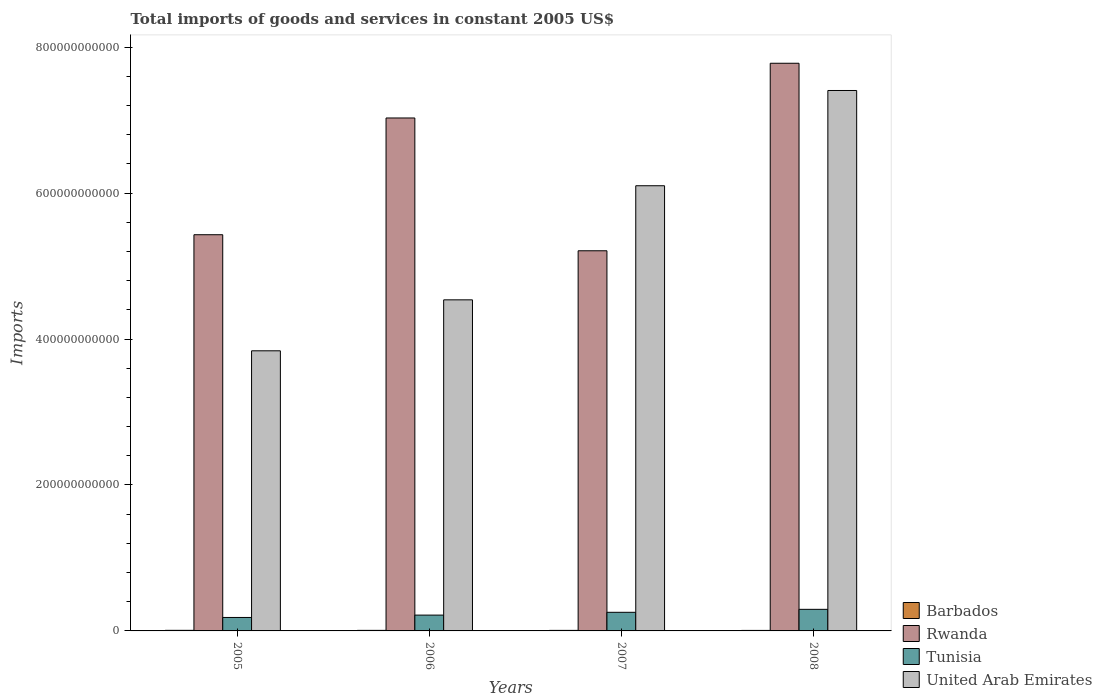How many different coloured bars are there?
Give a very brief answer. 4. How many groups of bars are there?
Give a very brief answer. 4. Are the number of bars per tick equal to the number of legend labels?
Your answer should be very brief. Yes. How many bars are there on the 3rd tick from the left?
Your answer should be compact. 4. How many bars are there on the 2nd tick from the right?
Give a very brief answer. 4. In how many cases, is the number of bars for a given year not equal to the number of legend labels?
Offer a very short reply. 0. What is the total imports of goods and services in United Arab Emirates in 2005?
Give a very brief answer. 3.84e+11. Across all years, what is the maximum total imports of goods and services in Tunisia?
Provide a short and direct response. 2.96e+1. Across all years, what is the minimum total imports of goods and services in Barbados?
Your response must be concise. 6.89e+08. In which year was the total imports of goods and services in Rwanda maximum?
Provide a short and direct response. 2008. In which year was the total imports of goods and services in Barbados minimum?
Keep it short and to the point. 2008. What is the total total imports of goods and services in Barbados in the graph?
Provide a short and direct response. 2.98e+09. What is the difference between the total imports of goods and services in United Arab Emirates in 2005 and that in 2006?
Offer a very short reply. -6.99e+1. What is the difference between the total imports of goods and services in Barbados in 2008 and the total imports of goods and services in Tunisia in 2006?
Provide a short and direct response. -2.10e+1. What is the average total imports of goods and services in Rwanda per year?
Make the answer very short. 6.36e+11. In the year 2008, what is the difference between the total imports of goods and services in Rwanda and total imports of goods and services in Tunisia?
Provide a short and direct response. 7.48e+11. In how many years, is the total imports of goods and services in United Arab Emirates greater than 160000000000 US$?
Keep it short and to the point. 4. What is the ratio of the total imports of goods and services in Barbados in 2005 to that in 2007?
Ensure brevity in your answer.  1.08. What is the difference between the highest and the second highest total imports of goods and services in United Arab Emirates?
Your answer should be compact. 1.31e+11. What is the difference between the highest and the lowest total imports of goods and services in Barbados?
Provide a short and direct response. 1.05e+08. In how many years, is the total imports of goods and services in Rwanda greater than the average total imports of goods and services in Rwanda taken over all years?
Provide a short and direct response. 2. Is the sum of the total imports of goods and services in United Arab Emirates in 2005 and 2007 greater than the maximum total imports of goods and services in Rwanda across all years?
Offer a terse response. Yes. Is it the case that in every year, the sum of the total imports of goods and services in Tunisia and total imports of goods and services in Rwanda is greater than the sum of total imports of goods and services in United Arab Emirates and total imports of goods and services in Barbados?
Make the answer very short. Yes. What does the 1st bar from the left in 2008 represents?
Provide a short and direct response. Barbados. What does the 1st bar from the right in 2005 represents?
Provide a succinct answer. United Arab Emirates. Is it the case that in every year, the sum of the total imports of goods and services in Barbados and total imports of goods and services in United Arab Emirates is greater than the total imports of goods and services in Tunisia?
Ensure brevity in your answer.  Yes. How many years are there in the graph?
Your response must be concise. 4. What is the difference between two consecutive major ticks on the Y-axis?
Give a very brief answer. 2.00e+11. Are the values on the major ticks of Y-axis written in scientific E-notation?
Your response must be concise. No. Where does the legend appear in the graph?
Your answer should be compact. Bottom right. What is the title of the graph?
Offer a very short reply. Total imports of goods and services in constant 2005 US$. What is the label or title of the X-axis?
Make the answer very short. Years. What is the label or title of the Y-axis?
Ensure brevity in your answer.  Imports. What is the Imports in Barbados in 2005?
Keep it short and to the point. 7.94e+08. What is the Imports of Rwanda in 2005?
Provide a short and direct response. 5.43e+11. What is the Imports in Tunisia in 2005?
Give a very brief answer. 1.84e+1. What is the Imports in United Arab Emirates in 2005?
Keep it short and to the point. 3.84e+11. What is the Imports in Barbados in 2006?
Offer a very short reply. 7.66e+08. What is the Imports in Rwanda in 2006?
Provide a succinct answer. 7.03e+11. What is the Imports of Tunisia in 2006?
Your answer should be very brief. 2.17e+1. What is the Imports in United Arab Emirates in 2006?
Your answer should be compact. 4.54e+11. What is the Imports in Barbados in 2007?
Your answer should be compact. 7.32e+08. What is the Imports in Rwanda in 2007?
Ensure brevity in your answer.  5.21e+11. What is the Imports in Tunisia in 2007?
Your answer should be compact. 2.55e+1. What is the Imports in United Arab Emirates in 2007?
Your response must be concise. 6.10e+11. What is the Imports in Barbados in 2008?
Ensure brevity in your answer.  6.89e+08. What is the Imports of Rwanda in 2008?
Make the answer very short. 7.78e+11. What is the Imports of Tunisia in 2008?
Your response must be concise. 2.96e+1. What is the Imports of United Arab Emirates in 2008?
Keep it short and to the point. 7.41e+11. Across all years, what is the maximum Imports of Barbados?
Provide a succinct answer. 7.94e+08. Across all years, what is the maximum Imports in Rwanda?
Your answer should be very brief. 7.78e+11. Across all years, what is the maximum Imports of Tunisia?
Your answer should be compact. 2.96e+1. Across all years, what is the maximum Imports in United Arab Emirates?
Offer a terse response. 7.41e+11. Across all years, what is the minimum Imports of Barbados?
Make the answer very short. 6.89e+08. Across all years, what is the minimum Imports of Rwanda?
Provide a succinct answer. 5.21e+11. Across all years, what is the minimum Imports of Tunisia?
Your response must be concise. 1.84e+1. Across all years, what is the minimum Imports of United Arab Emirates?
Provide a short and direct response. 3.84e+11. What is the total Imports of Barbados in the graph?
Your answer should be compact. 2.98e+09. What is the total Imports in Rwanda in the graph?
Your answer should be very brief. 2.54e+12. What is the total Imports in Tunisia in the graph?
Make the answer very short. 9.52e+1. What is the total Imports of United Arab Emirates in the graph?
Your response must be concise. 2.19e+12. What is the difference between the Imports of Barbados in 2005 and that in 2006?
Your response must be concise. 2.80e+07. What is the difference between the Imports in Rwanda in 2005 and that in 2006?
Keep it short and to the point. -1.60e+11. What is the difference between the Imports of Tunisia in 2005 and that in 2006?
Give a very brief answer. -3.24e+09. What is the difference between the Imports of United Arab Emirates in 2005 and that in 2006?
Offer a very short reply. -6.99e+1. What is the difference between the Imports in Barbados in 2005 and that in 2007?
Provide a short and direct response. 6.20e+07. What is the difference between the Imports in Rwanda in 2005 and that in 2007?
Your answer should be compact. 2.20e+1. What is the difference between the Imports of Tunisia in 2005 and that in 2007?
Keep it short and to the point. -7.08e+09. What is the difference between the Imports in United Arab Emirates in 2005 and that in 2007?
Offer a terse response. -2.26e+11. What is the difference between the Imports of Barbados in 2005 and that in 2008?
Provide a succinct answer. 1.05e+08. What is the difference between the Imports in Rwanda in 2005 and that in 2008?
Keep it short and to the point. -2.35e+11. What is the difference between the Imports of Tunisia in 2005 and that in 2008?
Your answer should be very brief. -1.11e+1. What is the difference between the Imports in United Arab Emirates in 2005 and that in 2008?
Keep it short and to the point. -3.57e+11. What is the difference between the Imports of Barbados in 2006 and that in 2007?
Make the answer very short. 3.40e+07. What is the difference between the Imports in Rwanda in 2006 and that in 2007?
Make the answer very short. 1.82e+11. What is the difference between the Imports of Tunisia in 2006 and that in 2007?
Keep it short and to the point. -3.83e+09. What is the difference between the Imports of United Arab Emirates in 2006 and that in 2007?
Your answer should be compact. -1.56e+11. What is the difference between the Imports of Barbados in 2006 and that in 2008?
Your answer should be very brief. 7.70e+07. What is the difference between the Imports in Rwanda in 2006 and that in 2008?
Give a very brief answer. -7.50e+1. What is the difference between the Imports of Tunisia in 2006 and that in 2008?
Your answer should be very brief. -7.89e+09. What is the difference between the Imports in United Arab Emirates in 2006 and that in 2008?
Provide a short and direct response. -2.87e+11. What is the difference between the Imports in Barbados in 2007 and that in 2008?
Provide a succinct answer. 4.30e+07. What is the difference between the Imports in Rwanda in 2007 and that in 2008?
Provide a short and direct response. -2.57e+11. What is the difference between the Imports in Tunisia in 2007 and that in 2008?
Your response must be concise. -4.06e+09. What is the difference between the Imports of United Arab Emirates in 2007 and that in 2008?
Ensure brevity in your answer.  -1.31e+11. What is the difference between the Imports of Barbados in 2005 and the Imports of Rwanda in 2006?
Provide a succinct answer. -7.02e+11. What is the difference between the Imports in Barbados in 2005 and the Imports in Tunisia in 2006?
Provide a short and direct response. -2.09e+1. What is the difference between the Imports in Barbados in 2005 and the Imports in United Arab Emirates in 2006?
Keep it short and to the point. -4.53e+11. What is the difference between the Imports of Rwanda in 2005 and the Imports of Tunisia in 2006?
Keep it short and to the point. 5.21e+11. What is the difference between the Imports in Rwanda in 2005 and the Imports in United Arab Emirates in 2006?
Keep it short and to the point. 8.92e+1. What is the difference between the Imports of Tunisia in 2005 and the Imports of United Arab Emirates in 2006?
Ensure brevity in your answer.  -4.35e+11. What is the difference between the Imports in Barbados in 2005 and the Imports in Rwanda in 2007?
Make the answer very short. -5.20e+11. What is the difference between the Imports in Barbados in 2005 and the Imports in Tunisia in 2007?
Your response must be concise. -2.47e+1. What is the difference between the Imports in Barbados in 2005 and the Imports in United Arab Emirates in 2007?
Keep it short and to the point. -6.09e+11. What is the difference between the Imports in Rwanda in 2005 and the Imports in Tunisia in 2007?
Ensure brevity in your answer.  5.17e+11. What is the difference between the Imports in Rwanda in 2005 and the Imports in United Arab Emirates in 2007?
Your answer should be compact. -6.71e+1. What is the difference between the Imports of Tunisia in 2005 and the Imports of United Arab Emirates in 2007?
Offer a very short reply. -5.92e+11. What is the difference between the Imports in Barbados in 2005 and the Imports in Rwanda in 2008?
Keep it short and to the point. -7.77e+11. What is the difference between the Imports in Barbados in 2005 and the Imports in Tunisia in 2008?
Keep it short and to the point. -2.88e+1. What is the difference between the Imports in Barbados in 2005 and the Imports in United Arab Emirates in 2008?
Your response must be concise. -7.40e+11. What is the difference between the Imports of Rwanda in 2005 and the Imports of Tunisia in 2008?
Provide a short and direct response. 5.13e+11. What is the difference between the Imports in Rwanda in 2005 and the Imports in United Arab Emirates in 2008?
Provide a succinct answer. -1.98e+11. What is the difference between the Imports in Tunisia in 2005 and the Imports in United Arab Emirates in 2008?
Provide a succinct answer. -7.22e+11. What is the difference between the Imports of Barbados in 2006 and the Imports of Rwanda in 2007?
Make the answer very short. -5.20e+11. What is the difference between the Imports in Barbados in 2006 and the Imports in Tunisia in 2007?
Offer a very short reply. -2.48e+1. What is the difference between the Imports in Barbados in 2006 and the Imports in United Arab Emirates in 2007?
Offer a very short reply. -6.09e+11. What is the difference between the Imports of Rwanda in 2006 and the Imports of Tunisia in 2007?
Keep it short and to the point. 6.77e+11. What is the difference between the Imports of Rwanda in 2006 and the Imports of United Arab Emirates in 2007?
Offer a very short reply. 9.29e+1. What is the difference between the Imports in Tunisia in 2006 and the Imports in United Arab Emirates in 2007?
Your answer should be very brief. -5.88e+11. What is the difference between the Imports of Barbados in 2006 and the Imports of Rwanda in 2008?
Offer a very short reply. -7.77e+11. What is the difference between the Imports of Barbados in 2006 and the Imports of Tunisia in 2008?
Give a very brief answer. -2.88e+1. What is the difference between the Imports of Barbados in 2006 and the Imports of United Arab Emirates in 2008?
Your answer should be very brief. -7.40e+11. What is the difference between the Imports in Rwanda in 2006 and the Imports in Tunisia in 2008?
Give a very brief answer. 6.73e+11. What is the difference between the Imports in Rwanda in 2006 and the Imports in United Arab Emirates in 2008?
Keep it short and to the point. -3.77e+1. What is the difference between the Imports in Tunisia in 2006 and the Imports in United Arab Emirates in 2008?
Ensure brevity in your answer.  -7.19e+11. What is the difference between the Imports in Barbados in 2007 and the Imports in Rwanda in 2008?
Your answer should be very brief. -7.77e+11. What is the difference between the Imports of Barbados in 2007 and the Imports of Tunisia in 2008?
Provide a short and direct response. -2.88e+1. What is the difference between the Imports in Barbados in 2007 and the Imports in United Arab Emirates in 2008?
Your response must be concise. -7.40e+11. What is the difference between the Imports of Rwanda in 2007 and the Imports of Tunisia in 2008?
Give a very brief answer. 4.91e+11. What is the difference between the Imports of Rwanda in 2007 and the Imports of United Arab Emirates in 2008?
Ensure brevity in your answer.  -2.20e+11. What is the difference between the Imports in Tunisia in 2007 and the Imports in United Arab Emirates in 2008?
Provide a succinct answer. -7.15e+11. What is the average Imports of Barbados per year?
Your answer should be compact. 7.45e+08. What is the average Imports in Rwanda per year?
Provide a short and direct response. 6.36e+11. What is the average Imports in Tunisia per year?
Offer a terse response. 2.38e+1. What is the average Imports of United Arab Emirates per year?
Offer a terse response. 5.47e+11. In the year 2005, what is the difference between the Imports in Barbados and Imports in Rwanda?
Your answer should be very brief. -5.42e+11. In the year 2005, what is the difference between the Imports of Barbados and Imports of Tunisia?
Your answer should be very brief. -1.76e+1. In the year 2005, what is the difference between the Imports of Barbados and Imports of United Arab Emirates?
Your answer should be compact. -3.83e+11. In the year 2005, what is the difference between the Imports in Rwanda and Imports in Tunisia?
Keep it short and to the point. 5.25e+11. In the year 2005, what is the difference between the Imports in Rwanda and Imports in United Arab Emirates?
Offer a very short reply. 1.59e+11. In the year 2005, what is the difference between the Imports of Tunisia and Imports of United Arab Emirates?
Provide a succinct answer. -3.65e+11. In the year 2006, what is the difference between the Imports in Barbados and Imports in Rwanda?
Ensure brevity in your answer.  -7.02e+11. In the year 2006, what is the difference between the Imports in Barbados and Imports in Tunisia?
Give a very brief answer. -2.09e+1. In the year 2006, what is the difference between the Imports of Barbados and Imports of United Arab Emirates?
Ensure brevity in your answer.  -4.53e+11. In the year 2006, what is the difference between the Imports in Rwanda and Imports in Tunisia?
Give a very brief answer. 6.81e+11. In the year 2006, what is the difference between the Imports of Rwanda and Imports of United Arab Emirates?
Your response must be concise. 2.49e+11. In the year 2006, what is the difference between the Imports of Tunisia and Imports of United Arab Emirates?
Make the answer very short. -4.32e+11. In the year 2007, what is the difference between the Imports of Barbados and Imports of Rwanda?
Provide a succinct answer. -5.20e+11. In the year 2007, what is the difference between the Imports of Barbados and Imports of Tunisia?
Ensure brevity in your answer.  -2.48e+1. In the year 2007, what is the difference between the Imports in Barbados and Imports in United Arab Emirates?
Give a very brief answer. -6.09e+11. In the year 2007, what is the difference between the Imports of Rwanda and Imports of Tunisia?
Provide a succinct answer. 4.95e+11. In the year 2007, what is the difference between the Imports in Rwanda and Imports in United Arab Emirates?
Your response must be concise. -8.91e+1. In the year 2007, what is the difference between the Imports in Tunisia and Imports in United Arab Emirates?
Your answer should be very brief. -5.85e+11. In the year 2008, what is the difference between the Imports of Barbados and Imports of Rwanda?
Make the answer very short. -7.77e+11. In the year 2008, what is the difference between the Imports in Barbados and Imports in Tunisia?
Offer a terse response. -2.89e+1. In the year 2008, what is the difference between the Imports in Barbados and Imports in United Arab Emirates?
Ensure brevity in your answer.  -7.40e+11. In the year 2008, what is the difference between the Imports in Rwanda and Imports in Tunisia?
Ensure brevity in your answer.  7.48e+11. In the year 2008, what is the difference between the Imports of Rwanda and Imports of United Arab Emirates?
Offer a terse response. 3.73e+1. In the year 2008, what is the difference between the Imports of Tunisia and Imports of United Arab Emirates?
Provide a succinct answer. -7.11e+11. What is the ratio of the Imports of Barbados in 2005 to that in 2006?
Ensure brevity in your answer.  1.04. What is the ratio of the Imports of Rwanda in 2005 to that in 2006?
Offer a very short reply. 0.77. What is the ratio of the Imports in Tunisia in 2005 to that in 2006?
Offer a very short reply. 0.85. What is the ratio of the Imports in United Arab Emirates in 2005 to that in 2006?
Ensure brevity in your answer.  0.85. What is the ratio of the Imports in Barbados in 2005 to that in 2007?
Offer a very short reply. 1.08. What is the ratio of the Imports in Rwanda in 2005 to that in 2007?
Make the answer very short. 1.04. What is the ratio of the Imports in Tunisia in 2005 to that in 2007?
Ensure brevity in your answer.  0.72. What is the ratio of the Imports of United Arab Emirates in 2005 to that in 2007?
Your response must be concise. 0.63. What is the ratio of the Imports of Barbados in 2005 to that in 2008?
Make the answer very short. 1.15. What is the ratio of the Imports of Rwanda in 2005 to that in 2008?
Your answer should be very brief. 0.7. What is the ratio of the Imports in Tunisia in 2005 to that in 2008?
Make the answer very short. 0.62. What is the ratio of the Imports of United Arab Emirates in 2005 to that in 2008?
Provide a succinct answer. 0.52. What is the ratio of the Imports of Barbados in 2006 to that in 2007?
Ensure brevity in your answer.  1.05. What is the ratio of the Imports in Rwanda in 2006 to that in 2007?
Your answer should be compact. 1.35. What is the ratio of the Imports in Tunisia in 2006 to that in 2007?
Offer a terse response. 0.85. What is the ratio of the Imports of United Arab Emirates in 2006 to that in 2007?
Your answer should be very brief. 0.74. What is the ratio of the Imports in Barbados in 2006 to that in 2008?
Your answer should be compact. 1.11. What is the ratio of the Imports in Rwanda in 2006 to that in 2008?
Keep it short and to the point. 0.9. What is the ratio of the Imports in Tunisia in 2006 to that in 2008?
Offer a terse response. 0.73. What is the ratio of the Imports of United Arab Emirates in 2006 to that in 2008?
Give a very brief answer. 0.61. What is the ratio of the Imports of Barbados in 2007 to that in 2008?
Provide a succinct answer. 1.06. What is the ratio of the Imports in Rwanda in 2007 to that in 2008?
Make the answer very short. 0.67. What is the ratio of the Imports of Tunisia in 2007 to that in 2008?
Offer a terse response. 0.86. What is the ratio of the Imports in United Arab Emirates in 2007 to that in 2008?
Keep it short and to the point. 0.82. What is the difference between the highest and the second highest Imports in Barbados?
Make the answer very short. 2.80e+07. What is the difference between the highest and the second highest Imports in Rwanda?
Your answer should be compact. 7.50e+1. What is the difference between the highest and the second highest Imports of Tunisia?
Offer a terse response. 4.06e+09. What is the difference between the highest and the second highest Imports of United Arab Emirates?
Your response must be concise. 1.31e+11. What is the difference between the highest and the lowest Imports of Barbados?
Offer a very short reply. 1.05e+08. What is the difference between the highest and the lowest Imports of Rwanda?
Your response must be concise. 2.57e+11. What is the difference between the highest and the lowest Imports of Tunisia?
Keep it short and to the point. 1.11e+1. What is the difference between the highest and the lowest Imports in United Arab Emirates?
Make the answer very short. 3.57e+11. 